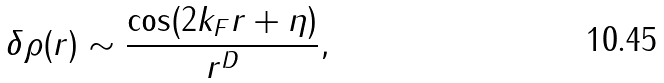Convert formula to latex. <formula><loc_0><loc_0><loc_500><loc_500>\delta \rho ( r ) \sim \frac { \cos ( 2 k _ { F } r + \eta ) } { r ^ { D } } ,</formula> 